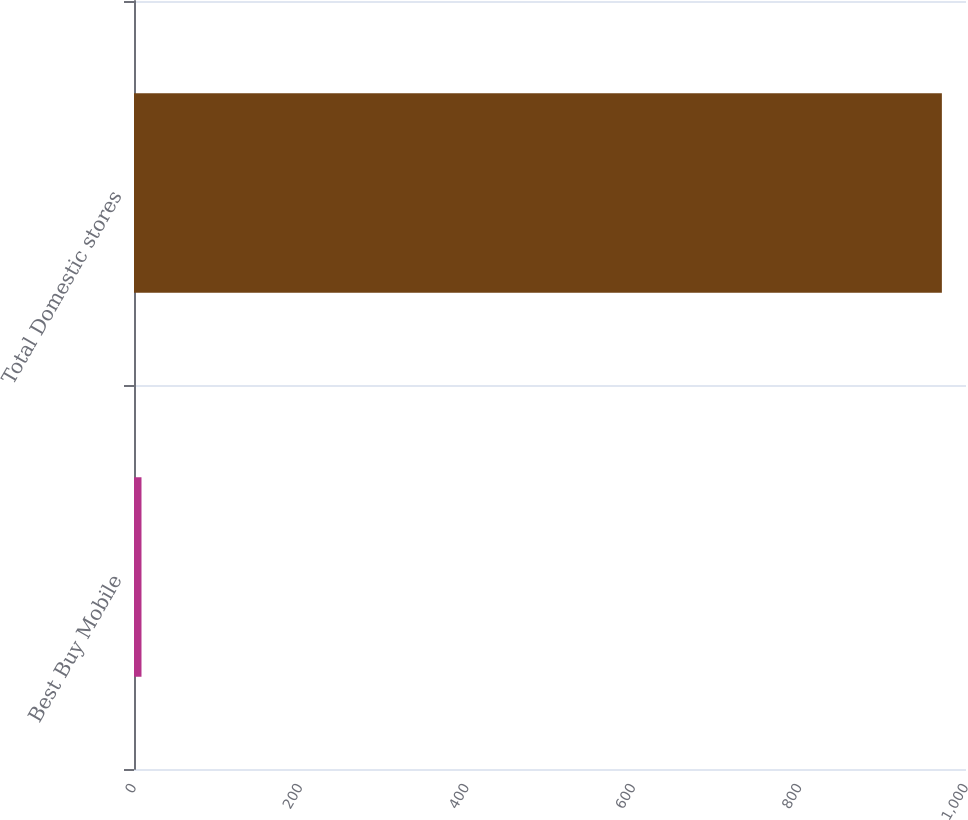Convert chart. <chart><loc_0><loc_0><loc_500><loc_500><bar_chart><fcel>Best Buy Mobile<fcel>Total Domestic stores<nl><fcel>9<fcel>971<nl></chart> 